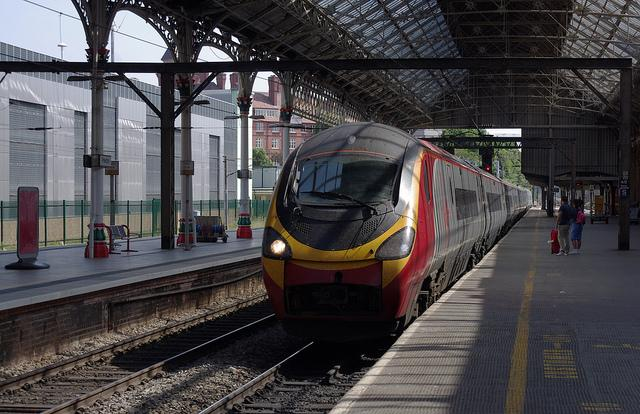Why are the people standing behind the yellow line? safety 